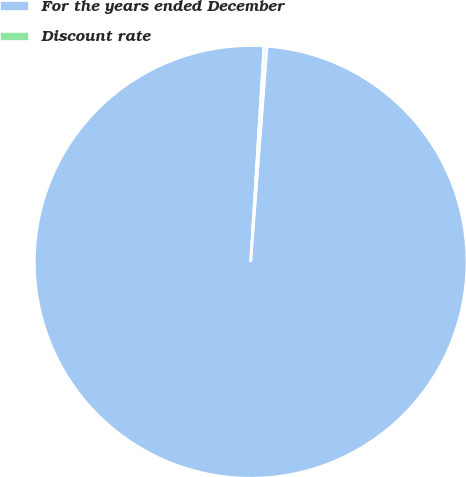Convert chart to OTSL. <chart><loc_0><loc_0><loc_500><loc_500><pie_chart><fcel>For the years ended December<fcel>Discount rate<nl><fcel>99.78%<fcel>0.22%<nl></chart> 